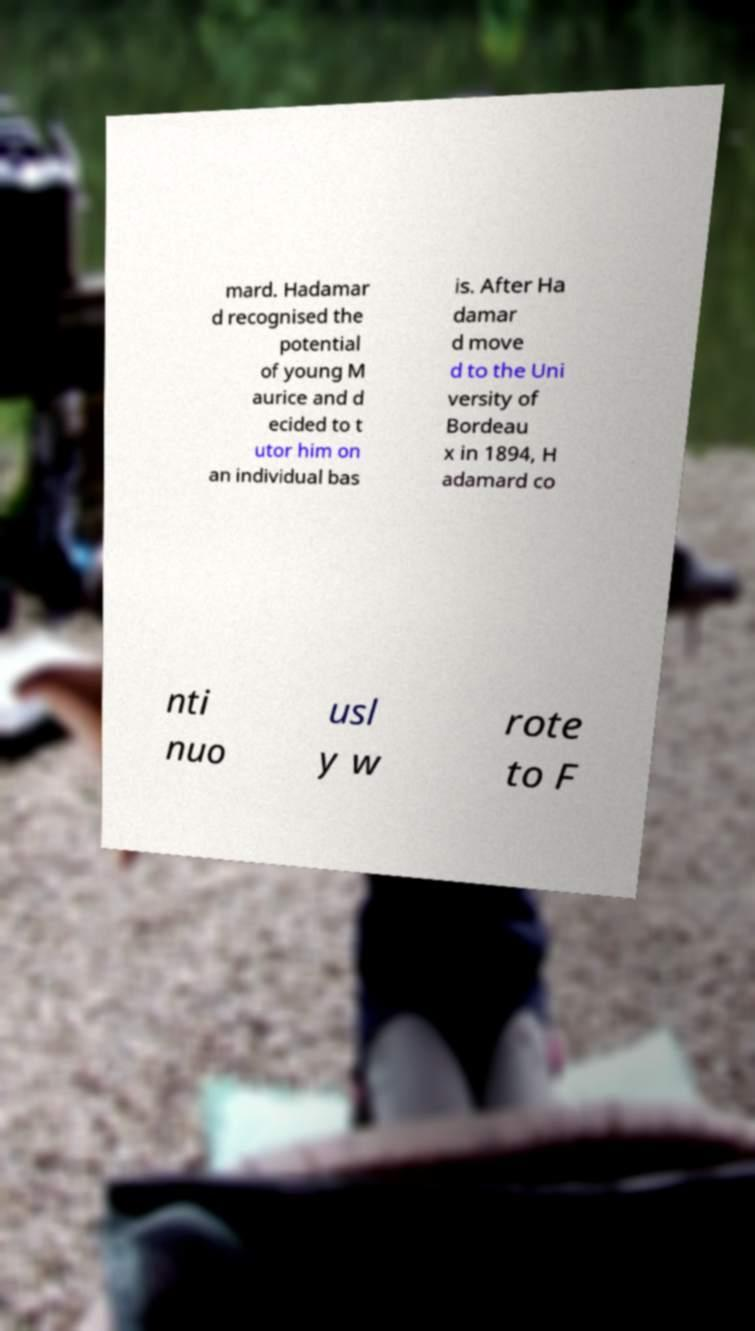What messages or text are displayed in this image? I need them in a readable, typed format. mard. Hadamar d recognised the potential of young M aurice and d ecided to t utor him on an individual bas is. After Ha damar d move d to the Uni versity of Bordeau x in 1894, H adamard co nti nuo usl y w rote to F 